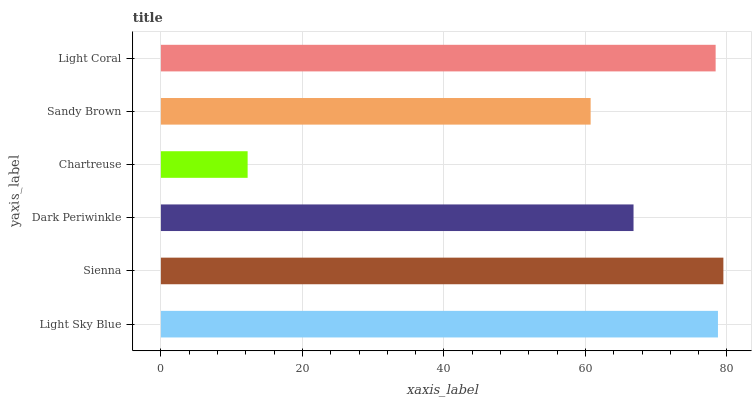Is Chartreuse the minimum?
Answer yes or no. Yes. Is Sienna the maximum?
Answer yes or no. Yes. Is Dark Periwinkle the minimum?
Answer yes or no. No. Is Dark Periwinkle the maximum?
Answer yes or no. No. Is Sienna greater than Dark Periwinkle?
Answer yes or no. Yes. Is Dark Periwinkle less than Sienna?
Answer yes or no. Yes. Is Dark Periwinkle greater than Sienna?
Answer yes or no. No. Is Sienna less than Dark Periwinkle?
Answer yes or no. No. Is Light Coral the high median?
Answer yes or no. Yes. Is Dark Periwinkle the low median?
Answer yes or no. Yes. Is Sienna the high median?
Answer yes or no. No. Is Sienna the low median?
Answer yes or no. No. 